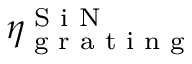<formula> <loc_0><loc_0><loc_500><loc_500>\eta _ { g r a t i n g } ^ { S i N }</formula> 